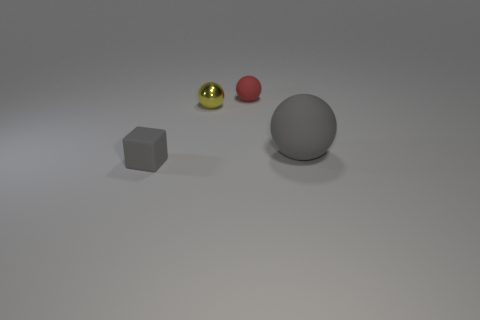Is there any other thing that has the same material as the yellow thing?
Offer a very short reply. No. The other thing that is the same color as the large object is what size?
Your answer should be compact. Small. There is a gray rubber object left of the small rubber thing that is behind the matte object that is left of the small rubber ball; how big is it?
Give a very brief answer. Small. There is another tiny thing that is the same shape as the metallic object; what color is it?
Your response must be concise. Red. Is the metallic thing the same size as the gray ball?
Your answer should be compact. No. There is a gray object that is to the left of the large rubber sphere; what is it made of?
Make the answer very short. Rubber. How many other objects are there of the same shape as the small yellow object?
Give a very brief answer. 2. Does the small red thing have the same shape as the big object?
Offer a very short reply. Yes. Are there any big gray rubber balls in front of the large matte object?
Provide a succinct answer. No. What number of objects are big spheres or big red metal spheres?
Offer a terse response. 1. 